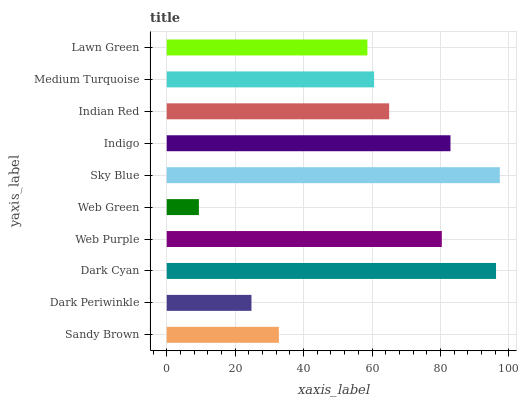Is Web Green the minimum?
Answer yes or no. Yes. Is Sky Blue the maximum?
Answer yes or no. Yes. Is Dark Periwinkle the minimum?
Answer yes or no. No. Is Dark Periwinkle the maximum?
Answer yes or no. No. Is Sandy Brown greater than Dark Periwinkle?
Answer yes or no. Yes. Is Dark Periwinkle less than Sandy Brown?
Answer yes or no. Yes. Is Dark Periwinkle greater than Sandy Brown?
Answer yes or no. No. Is Sandy Brown less than Dark Periwinkle?
Answer yes or no. No. Is Indian Red the high median?
Answer yes or no. Yes. Is Medium Turquoise the low median?
Answer yes or no. Yes. Is Web Purple the high median?
Answer yes or no. No. Is Indigo the low median?
Answer yes or no. No. 